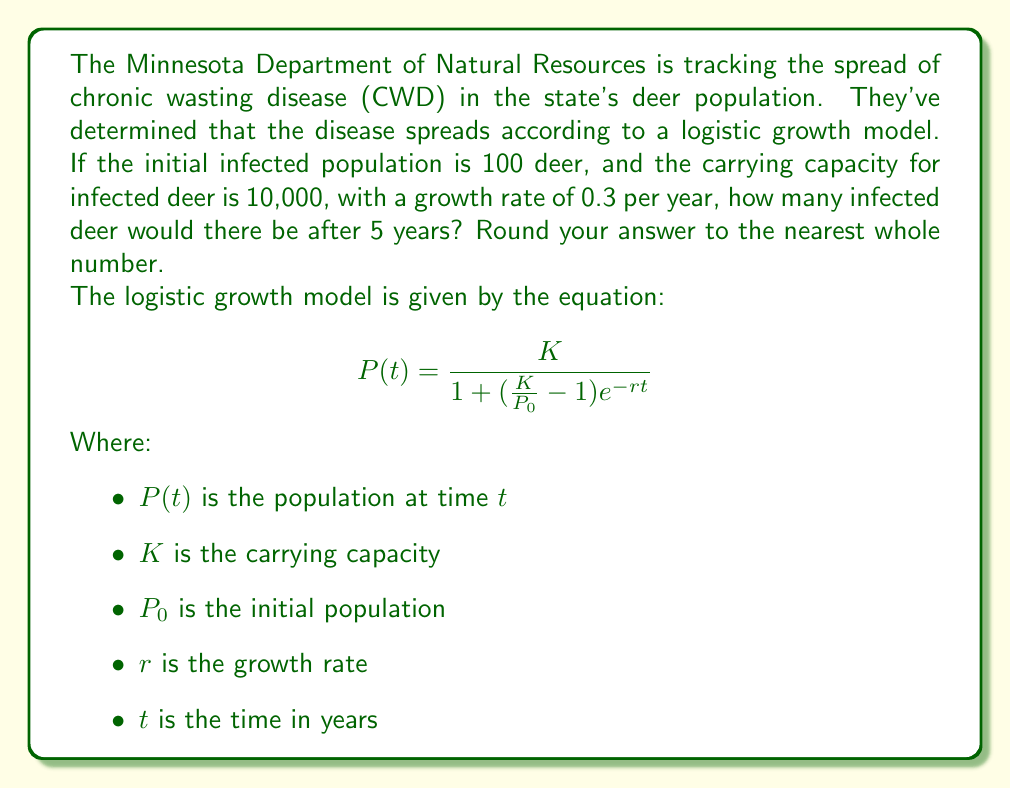Can you solve this math problem? To solve this problem, we'll use the logistic growth model equation and plug in the given values:

$K = 10,000$ (carrying capacity)
$P_0 = 100$ (initial infected population)
$r = 0.3$ (growth rate per year)
$t = 5$ (time in years)

Let's substitute these values into the equation:

$$P(5) = \frac{10,000}{1 + (\frac{10,000}{100} - 1)e^{-0.3(5)}}$$

Now, let's solve this step by step:

1) First, simplify the fraction inside the parentheses:
   $$\frac{10,000}{100} - 1 = 100 - 1 = 99$$

2) Now our equation looks like this:
   $$P(5) = \frac{10,000}{1 + (99)e^{-0.3(5)}}$$

3) Calculate the exponent:
   $-0.3(5) = -1.5$

4) Now we have:
   $$P(5) = \frac{10,000}{1 + 99e^{-1.5}}$$

5) Calculate $e^{-1.5}$:
   $e^{-1.5} \approx 0.2231$

6) Multiply:
   $99 * 0.2231 \approx 22.0869$

7) Add 1:
   $1 + 22.0869 = 23.0869$

8) Now we have:
   $$P(5) = \frac{10,000}{23.0869}$$

9) Divide:
   $P(5) \approx 433.1479$

10) Rounding to the nearest whole number:
    $P(5) \approx 433$
Answer: 433 infected deer 